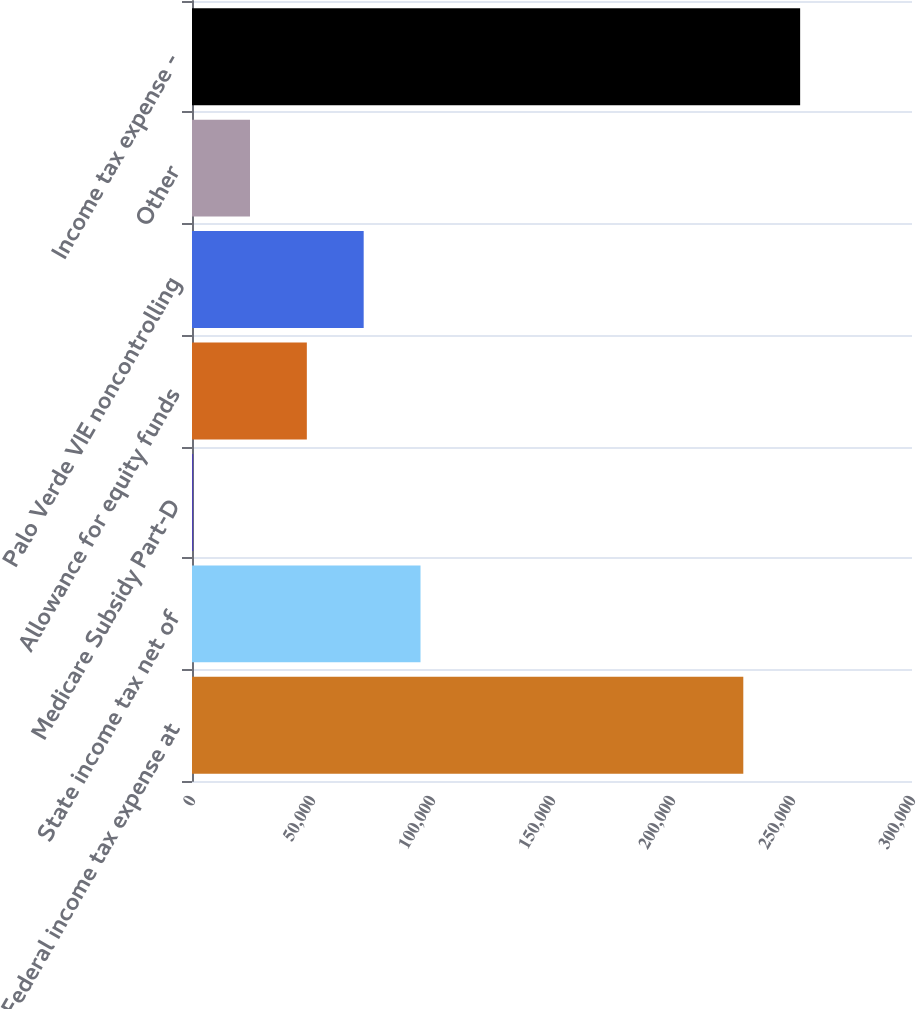Convert chart to OTSL. <chart><loc_0><loc_0><loc_500><loc_500><bar_chart><fcel>Federal income tax expense at<fcel>State income tax net of<fcel>Medicare Subsidy Part-D<fcel>Allowance for equity funds<fcel>Palo Verde VIE noncontrolling<fcel>Other<fcel>Income tax expense -<nl><fcel>229709<fcel>95216.6<fcel>483<fcel>47849.8<fcel>71533.2<fcel>24166.4<fcel>253392<nl></chart> 